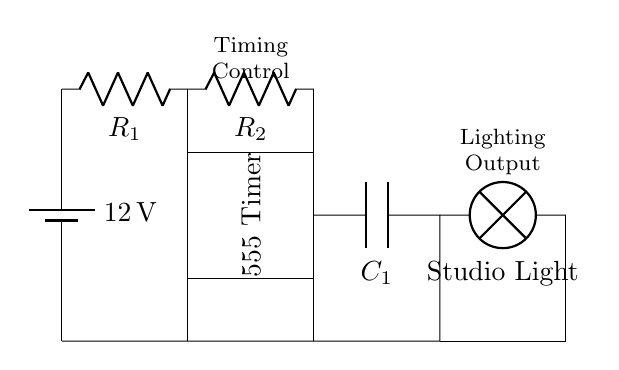What is the main component used for timing in this circuit? The main component used for timing is the 555 Timer, which is clearly labeled in the circuit diagram. This IC is commonly used for creating time delays in various applications including lighting systems.
Answer: 555 Timer What is the voltage of the power supply? The circuit shows a battery labeled with a voltage of twelve volts. This voltage is critical as it powers the entire timer circuit and its components.
Answer: 12 volts How many resistors are present in the circuit? Upon analyzing the circuit, there are two resistors labeled as R1 and R2. Each is connected in series, contributing to the timing function when paired with the capacitor.
Answer: 2 What component controls the timing function of the circuit? The timing is controlled by the combination of resistors R1, R2, and the capacitor C1. The 555 Timer uses these components to determine the duration of the timed output.
Answer: R1, R2, C1 What type of output does this timer circuit provide? The output of this circuit is connected to a studio light, which is marked in the diagram. The lamp receives power based on the timing cycle established by the 555 Timer.
Answer: Studio light What happens if resistor R1 is increased in value? Increasing the value of R1 would cause the timing interval of the circuit to lengthen. This is because a higher resistance will take more time to charge the capacitor, leading to a longer delay before the output signal is activated.
Answer: Timing interval lengthens 